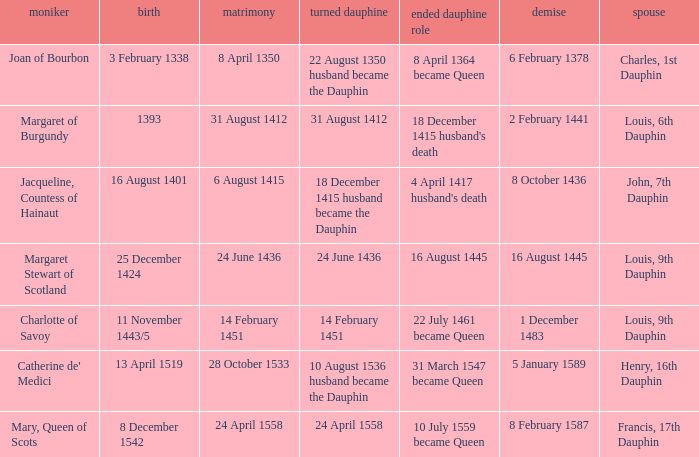Who has a birth of 16 august 1401? Jacqueline, Countess of Hainaut. 